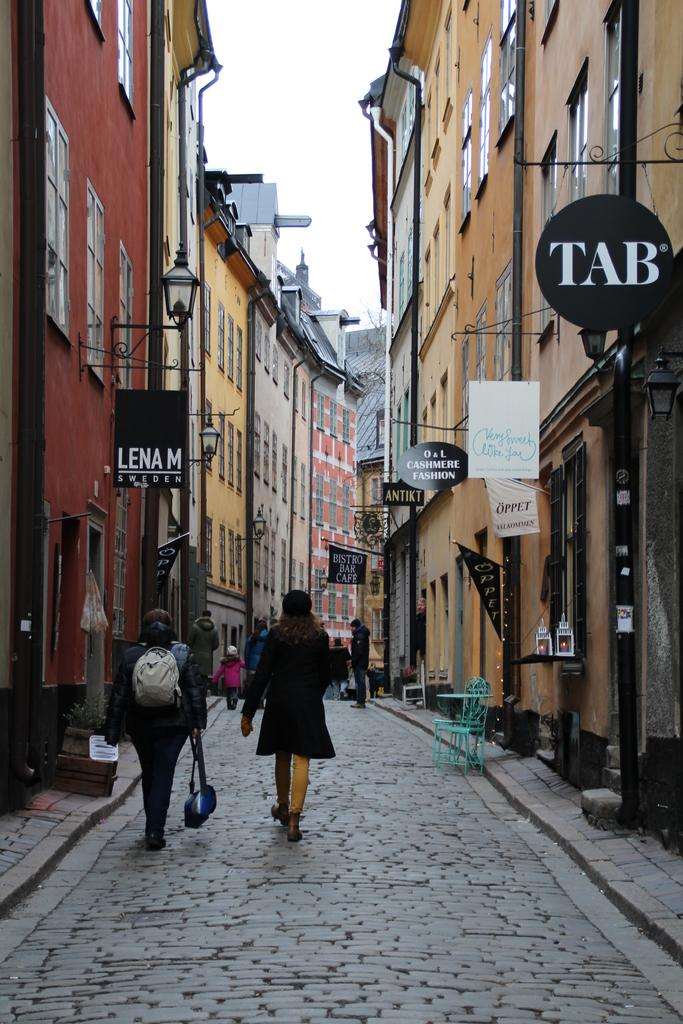Who or what can be seen in the image? There are people in the image. What objects are present in the image that provide illumination? There are lights in the image. What type of furniture is visible in the image? There are chairs in the image. What type of structures can be seen in the image? There are buildings in the image. What can be seen in the background of the image? The sky is visible in the background of the image. What type of advice is being given in the image? There is no indication of any advice being given in the image. Is there a jail visible in the image? No, there is no jail present in the image. 